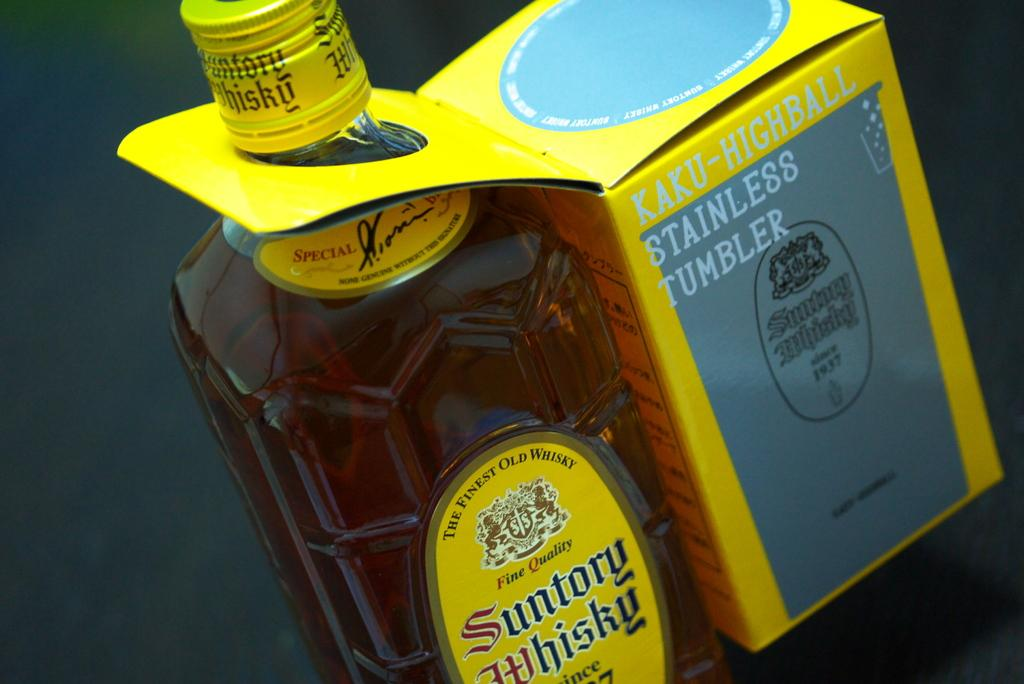What type of bottle is present in the image? There is a whisky bottle in the image. What type of band is playing in the background of the image? There is no band present in the image; it only features a whisky bottle. How many cattle can be seen grazing in the image? There are no cattle present in the image; it only features a whisky bottle. 